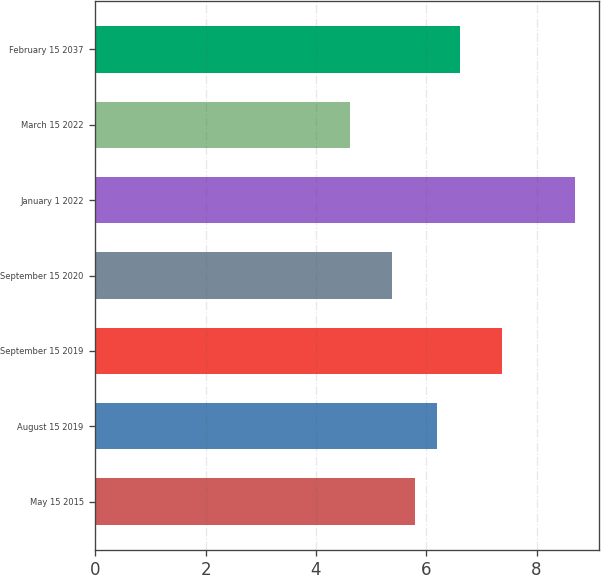Convert chart to OTSL. <chart><loc_0><loc_0><loc_500><loc_500><bar_chart><fcel>May 15 2015<fcel>August 15 2019<fcel>September 15 2019<fcel>September 15 2020<fcel>January 1 2022<fcel>March 15 2022<fcel>February 15 2037<nl><fcel>5.79<fcel>6.2<fcel>7.38<fcel>5.38<fcel>8.7<fcel>4.62<fcel>6.61<nl></chart> 